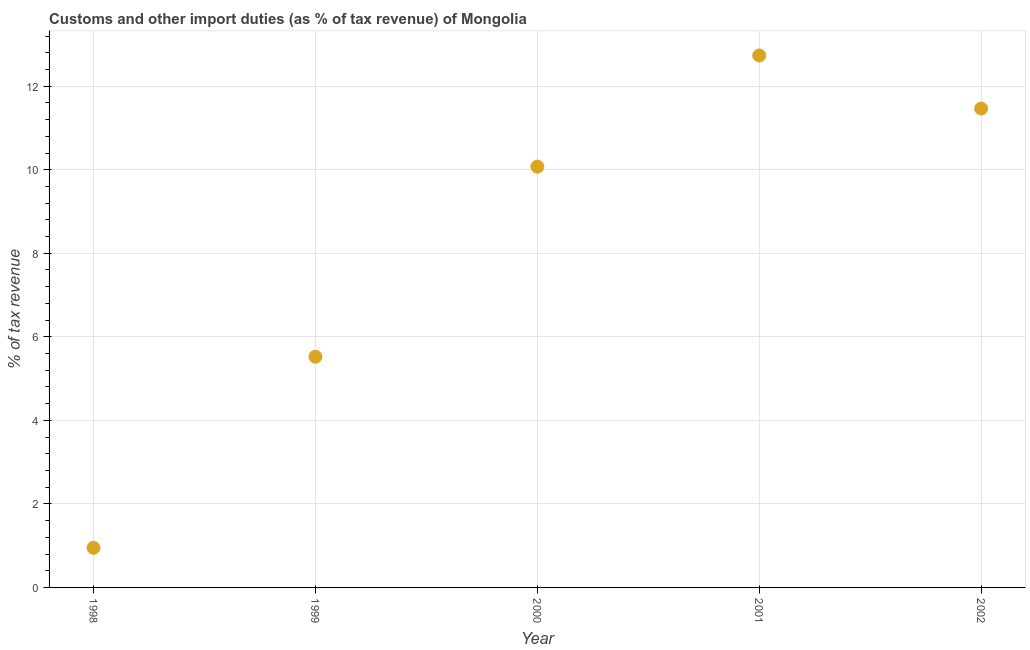What is the customs and other import duties in 1998?
Keep it short and to the point. 0.95. Across all years, what is the maximum customs and other import duties?
Make the answer very short. 12.74. Across all years, what is the minimum customs and other import duties?
Your answer should be compact. 0.95. In which year was the customs and other import duties maximum?
Ensure brevity in your answer.  2001. What is the sum of the customs and other import duties?
Your answer should be very brief. 40.75. What is the difference between the customs and other import duties in 1999 and 2002?
Give a very brief answer. -5.94. What is the average customs and other import duties per year?
Offer a terse response. 8.15. What is the median customs and other import duties?
Give a very brief answer. 10.07. Do a majority of the years between 1998 and 1999 (inclusive) have customs and other import duties greater than 3.6 %?
Your response must be concise. No. What is the ratio of the customs and other import duties in 1999 to that in 2000?
Your response must be concise. 0.55. Is the customs and other import duties in 1998 less than that in 2002?
Offer a terse response. Yes. Is the difference between the customs and other import duties in 1998 and 2001 greater than the difference between any two years?
Provide a succinct answer. Yes. What is the difference between the highest and the second highest customs and other import duties?
Offer a terse response. 1.27. What is the difference between the highest and the lowest customs and other import duties?
Your answer should be compact. 11.79. In how many years, is the customs and other import duties greater than the average customs and other import duties taken over all years?
Your answer should be very brief. 3. Does the customs and other import duties monotonically increase over the years?
Provide a short and direct response. No. How many years are there in the graph?
Your answer should be compact. 5. What is the difference between two consecutive major ticks on the Y-axis?
Provide a short and direct response. 2. Are the values on the major ticks of Y-axis written in scientific E-notation?
Give a very brief answer. No. Does the graph contain any zero values?
Ensure brevity in your answer.  No. Does the graph contain grids?
Ensure brevity in your answer.  Yes. What is the title of the graph?
Keep it short and to the point. Customs and other import duties (as % of tax revenue) of Mongolia. What is the label or title of the X-axis?
Ensure brevity in your answer.  Year. What is the label or title of the Y-axis?
Your response must be concise. % of tax revenue. What is the % of tax revenue in 1998?
Provide a short and direct response. 0.95. What is the % of tax revenue in 1999?
Your response must be concise. 5.52. What is the % of tax revenue in 2000?
Offer a terse response. 10.07. What is the % of tax revenue in 2001?
Offer a very short reply. 12.74. What is the % of tax revenue in 2002?
Make the answer very short. 11.46. What is the difference between the % of tax revenue in 1998 and 1999?
Make the answer very short. -4.58. What is the difference between the % of tax revenue in 1998 and 2000?
Your response must be concise. -9.13. What is the difference between the % of tax revenue in 1998 and 2001?
Keep it short and to the point. -11.79. What is the difference between the % of tax revenue in 1998 and 2002?
Your answer should be very brief. -10.52. What is the difference between the % of tax revenue in 1999 and 2000?
Your answer should be very brief. -4.55. What is the difference between the % of tax revenue in 1999 and 2001?
Your answer should be very brief. -7.21. What is the difference between the % of tax revenue in 1999 and 2002?
Offer a very short reply. -5.94. What is the difference between the % of tax revenue in 2000 and 2001?
Your answer should be very brief. -2.66. What is the difference between the % of tax revenue in 2000 and 2002?
Offer a very short reply. -1.39. What is the difference between the % of tax revenue in 2001 and 2002?
Provide a short and direct response. 1.27. What is the ratio of the % of tax revenue in 1998 to that in 1999?
Provide a short and direct response. 0.17. What is the ratio of the % of tax revenue in 1998 to that in 2000?
Keep it short and to the point. 0.09. What is the ratio of the % of tax revenue in 1998 to that in 2001?
Provide a short and direct response. 0.07. What is the ratio of the % of tax revenue in 1998 to that in 2002?
Make the answer very short. 0.08. What is the ratio of the % of tax revenue in 1999 to that in 2000?
Offer a very short reply. 0.55. What is the ratio of the % of tax revenue in 1999 to that in 2001?
Offer a very short reply. 0.43. What is the ratio of the % of tax revenue in 1999 to that in 2002?
Offer a terse response. 0.48. What is the ratio of the % of tax revenue in 2000 to that in 2001?
Provide a short and direct response. 0.79. What is the ratio of the % of tax revenue in 2000 to that in 2002?
Offer a very short reply. 0.88. What is the ratio of the % of tax revenue in 2001 to that in 2002?
Offer a very short reply. 1.11. 